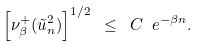Convert formula to latex. <formula><loc_0><loc_0><loc_500><loc_500>\left [ \nu ^ { + } _ { \beta } ( \tilde { u } _ { n } ^ { 2 } ) \right ] ^ { 1 / 2 } \ \leq \ C \ e ^ { - \beta n } .</formula> 